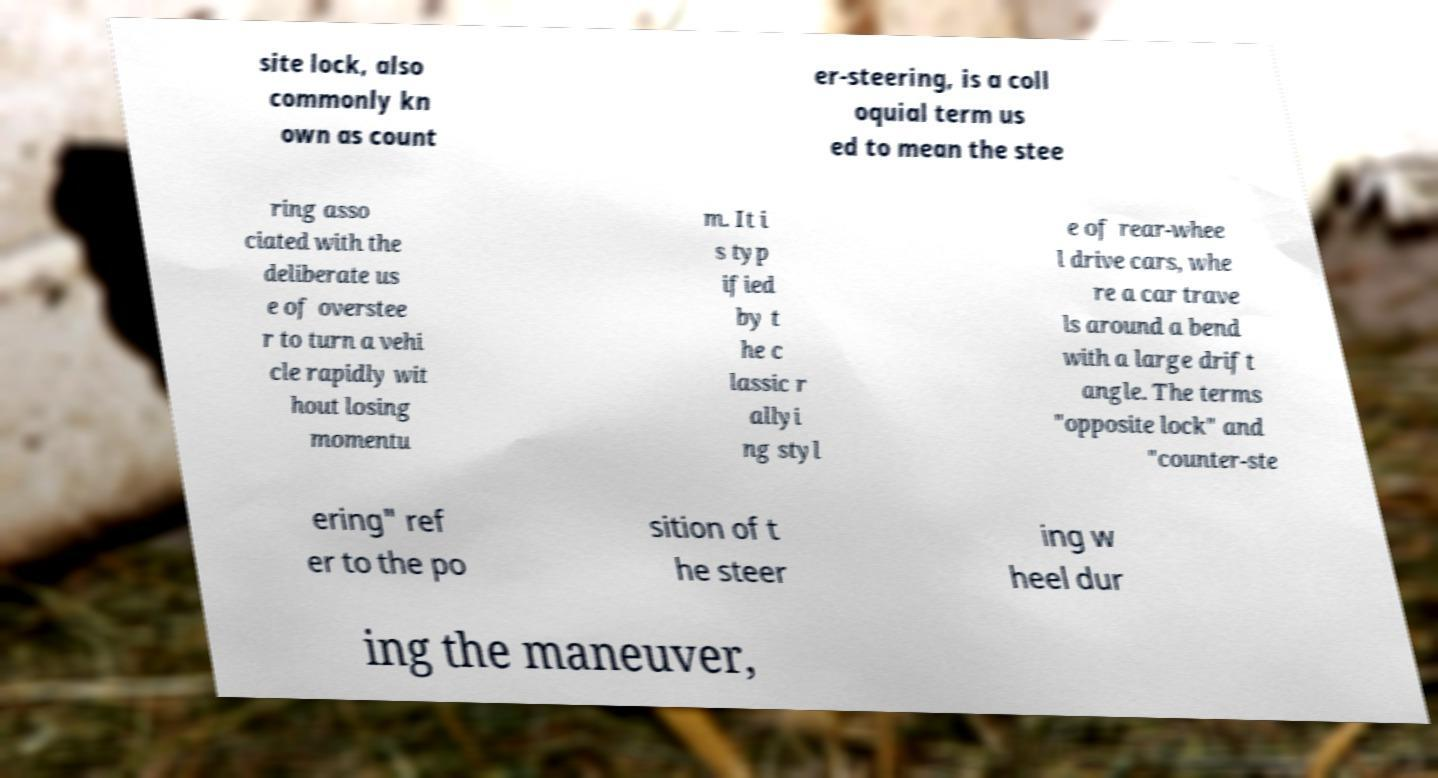I need the written content from this picture converted into text. Can you do that? site lock, also commonly kn own as count er-steering, is a coll oquial term us ed to mean the stee ring asso ciated with the deliberate us e of overstee r to turn a vehi cle rapidly wit hout losing momentu m. It i s typ ified by t he c lassic r allyi ng styl e of rear-whee l drive cars, whe re a car trave ls around a bend with a large drift angle. The terms "opposite lock" and "counter-ste ering" ref er to the po sition of t he steer ing w heel dur ing the maneuver, 